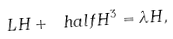Convert formula to latex. <formula><loc_0><loc_0><loc_500><loc_500>L H + \ h a l f H ^ { 3 } = \lambda H ,</formula> 